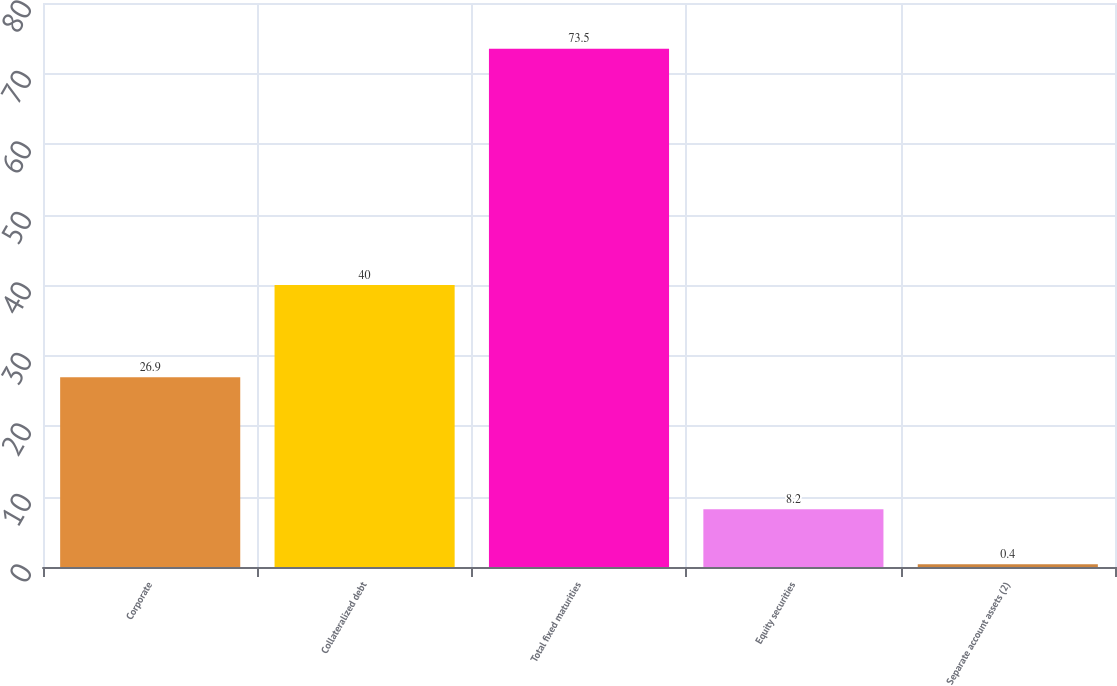Convert chart to OTSL. <chart><loc_0><loc_0><loc_500><loc_500><bar_chart><fcel>Corporate<fcel>Collateralized debt<fcel>Total fixed maturities<fcel>Equity securities<fcel>Separate account assets (2)<nl><fcel>26.9<fcel>40<fcel>73.5<fcel>8.2<fcel>0.4<nl></chart> 